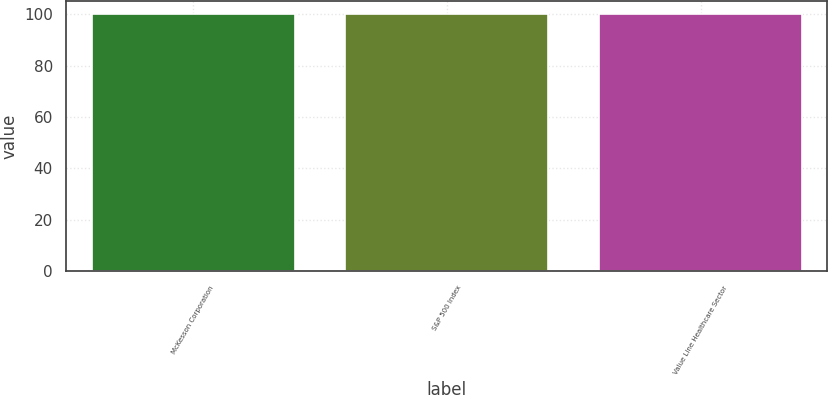Convert chart to OTSL. <chart><loc_0><loc_0><loc_500><loc_500><bar_chart><fcel>McKesson Corporation<fcel>S&P 500 Index<fcel>Value Line Healthcare Sector<nl><fcel>100<fcel>100.1<fcel>100.2<nl></chart> 